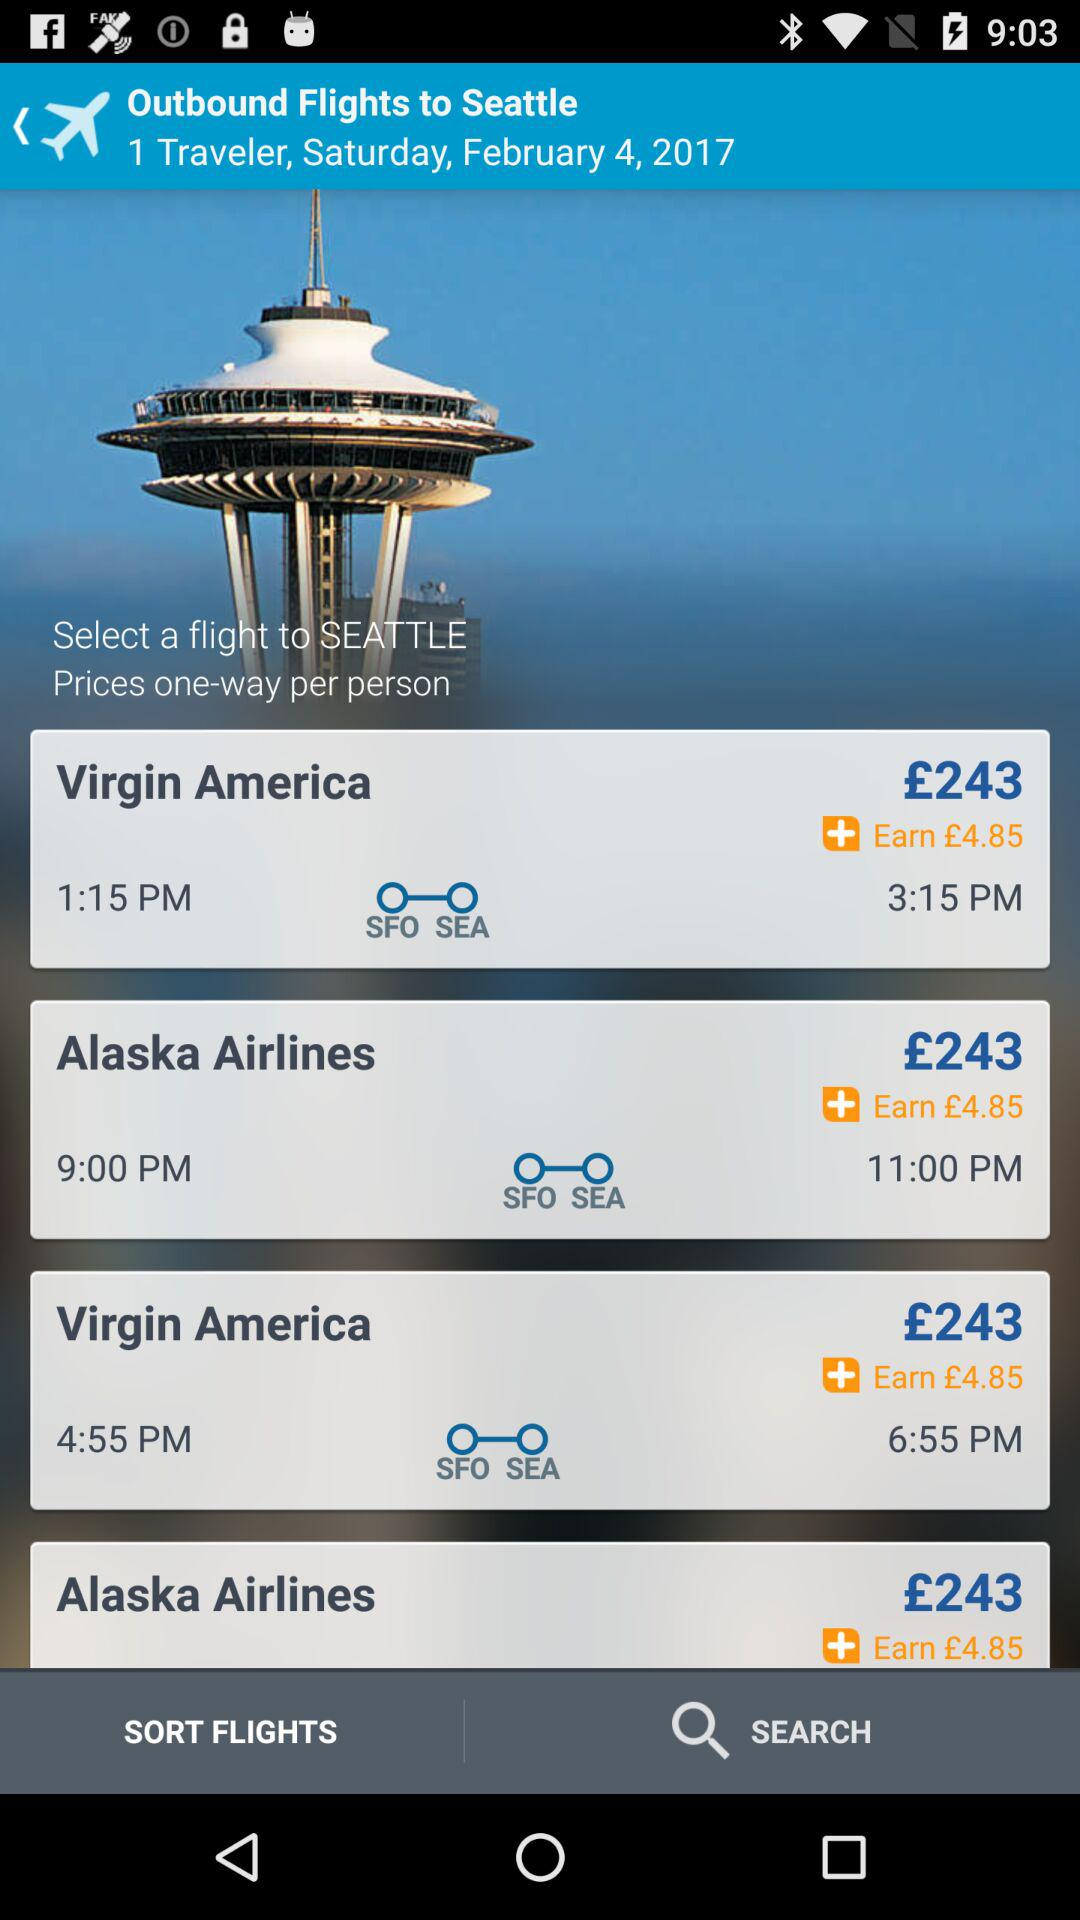What is the destination location? The destination location is Seattle. 